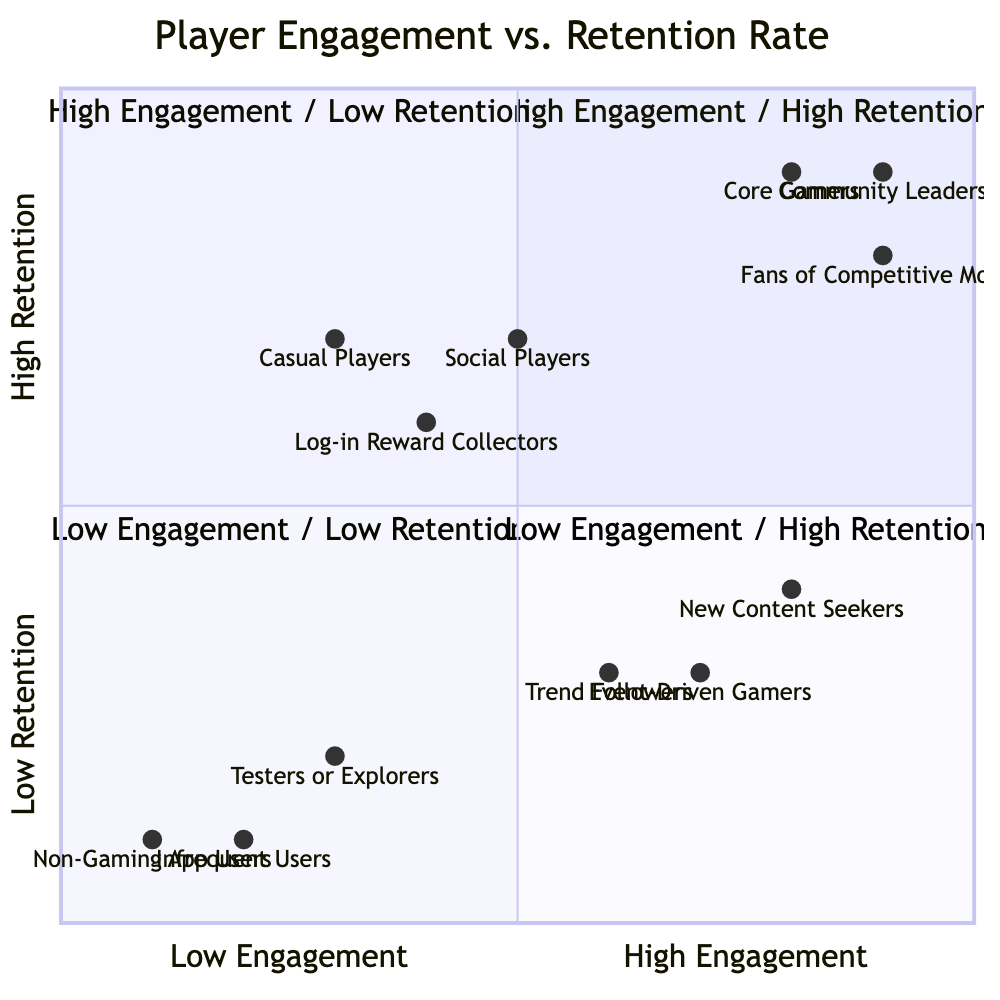What are the examples of players in the High Engagement / High Retention quadrant? The High Engagement / High Retention quadrant lists the examples: Core Gamers, Fans of Competitive Modes, and Community Leaders.
Answer: Core Gamers, Fans of Competitive Modes, Community Leaders How many examples are listed in the Low Engagement / High Retention quadrant? The Low Engagement / High Retention quadrant contains three examples: Casual Players, Log-in Reward Collectors, and Social Players. Thus, there are three examples.
Answer: 3 Which in-app purchase items are associated with Event-Driven Gamers? The in-app purchase items for Event-Driven Gamers in the High Engagement / Low Retention quadrant include Limited-Time Power-Ups, Event-Specific Items, and New Release Bundles.
Answer: Limited-Time Power-Ups, Event-Specific Items, New Release Bundles What is the engagement level of Community Leaders? Community Leaders are positioned in the High Engagement / High Retention quadrant, indicating a high level of engagement.
Answer: High Which quadrant do Casual Players belong to? Casual Players are located in the Low Engagement / High Retention quadrant, as reflected by their characteristics and behaviors concerning engagement and retention.
Answer: Low Engagement / High Retention How do the in-app purchase behaviors of players in the Low Engagement / Low Retention quadrant differ from those in the High Engagement / High Retention quadrant? Players in the Low Engagement / Low Retention quadrant typically purchase Entry Promotions, Welcome Bundles, and Sample Power-Ups, while those in the High Engagement / High Retention quadrant spend on Seasonal Pass Subscriptions, Exclusive Character Skins, and Competitive Mode Entries, showing a trend towards less committed purchases in the lower quadrant.
Answer: Differing purchase behaviors What is the retention level of New Content Seekers? New Content Seekers are placed in the High Engagement / Low Retention quadrant, indicating a low retention level.
Answer: Low In which quadrant do Power-Ups relevant to players primarily belong? Power-Ups are associated with multiple quadrants, specifically in the High Engagement / Low Retention quadrant for Limited-Time Power-Ups and in the Low Engagement / Low Retention quadrant for Sample Power-Ups.
Answer: High Engagement / Low Retention and Low Engagement / Low Retention 